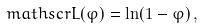<formula> <loc_0><loc_0><loc_500><loc_500>\ m a t h s c r { L } ( \varphi ) = \ln ( 1 - \varphi ) \, ,</formula> 